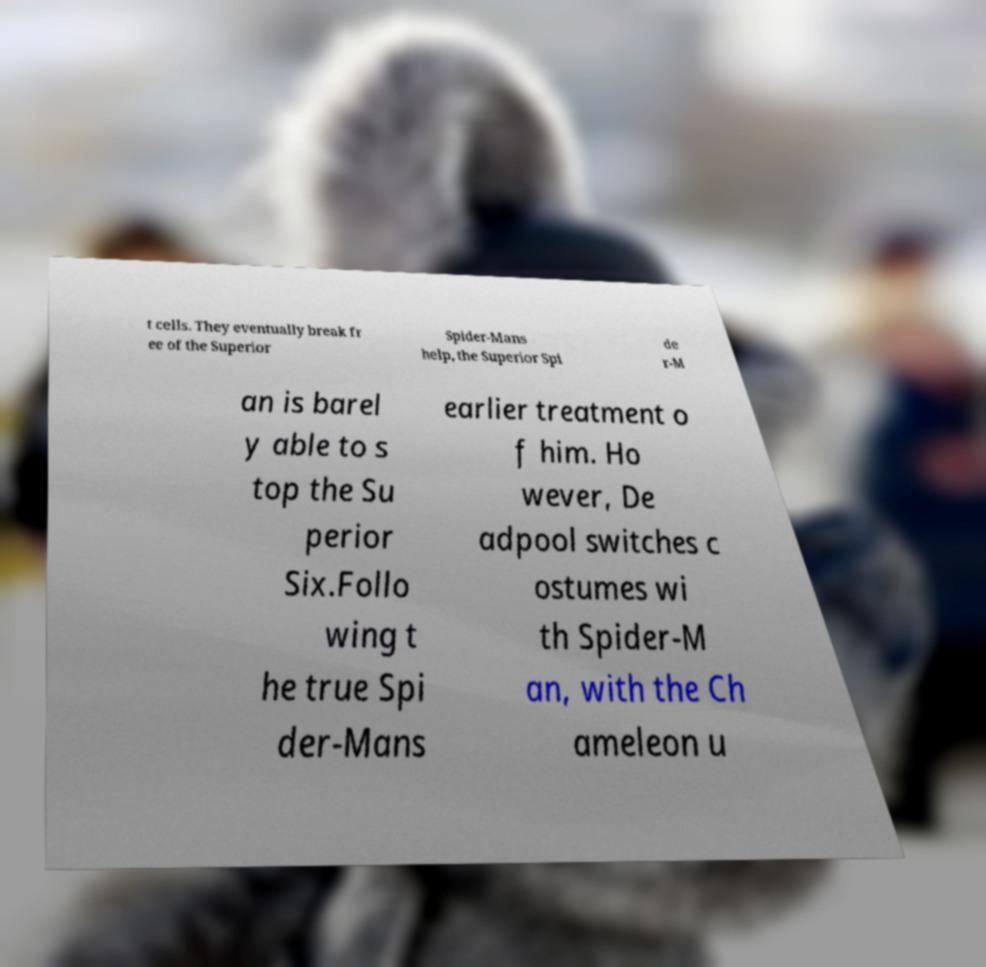Can you accurately transcribe the text from the provided image for me? t cells. They eventually break fr ee of the Superior Spider-Mans help, the Superior Spi de r-M an is barel y able to s top the Su perior Six.Follo wing t he true Spi der-Mans earlier treatment o f him. Ho wever, De adpool switches c ostumes wi th Spider-M an, with the Ch ameleon u 